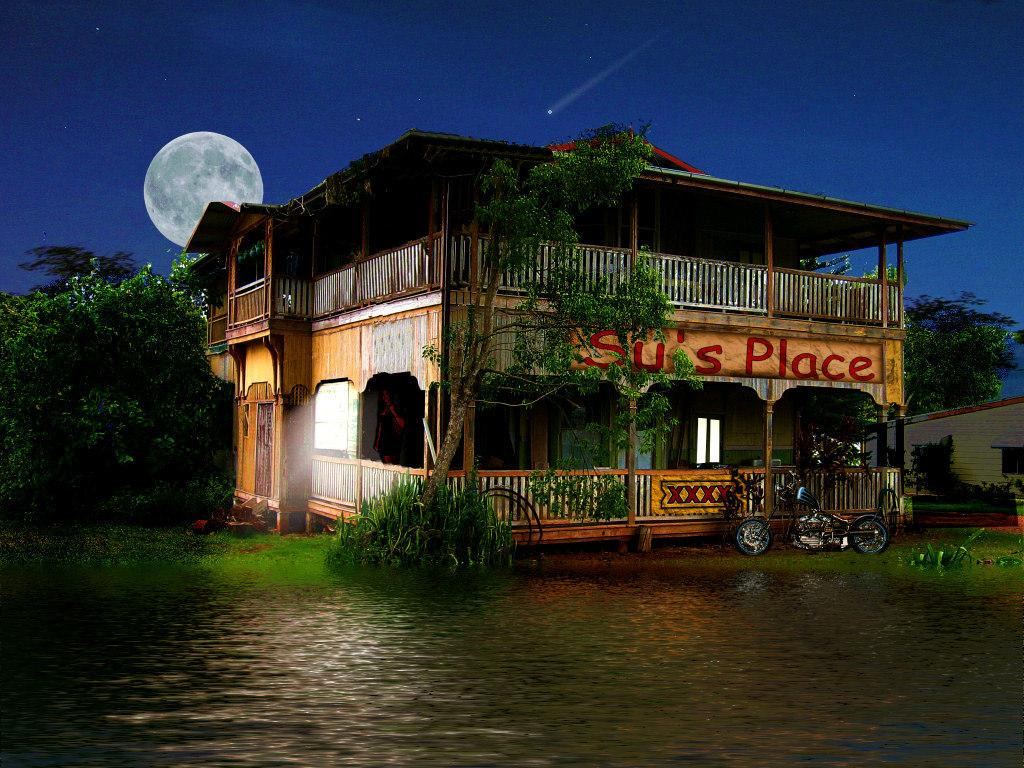What type of structures can be seen in the image? There are houses in the image. What other natural elements are present in the image? There are trees in the image. Can you describe the bike in the image? There is a bike parked in front of a house in the image. What is in front of the house with the bike? There is water in front of a house in the image. What celestial body is visible in the sky at the top of the image? The moon is visible in the sky at the top of the image. What type of engine can be seen powering the bike in the image? There is no engine visible in the image; the bike is parked and not in use. How many friends are sitting on the bike in the image? There are no friends sitting on the bike in the image; the bike is parked and not in use. 